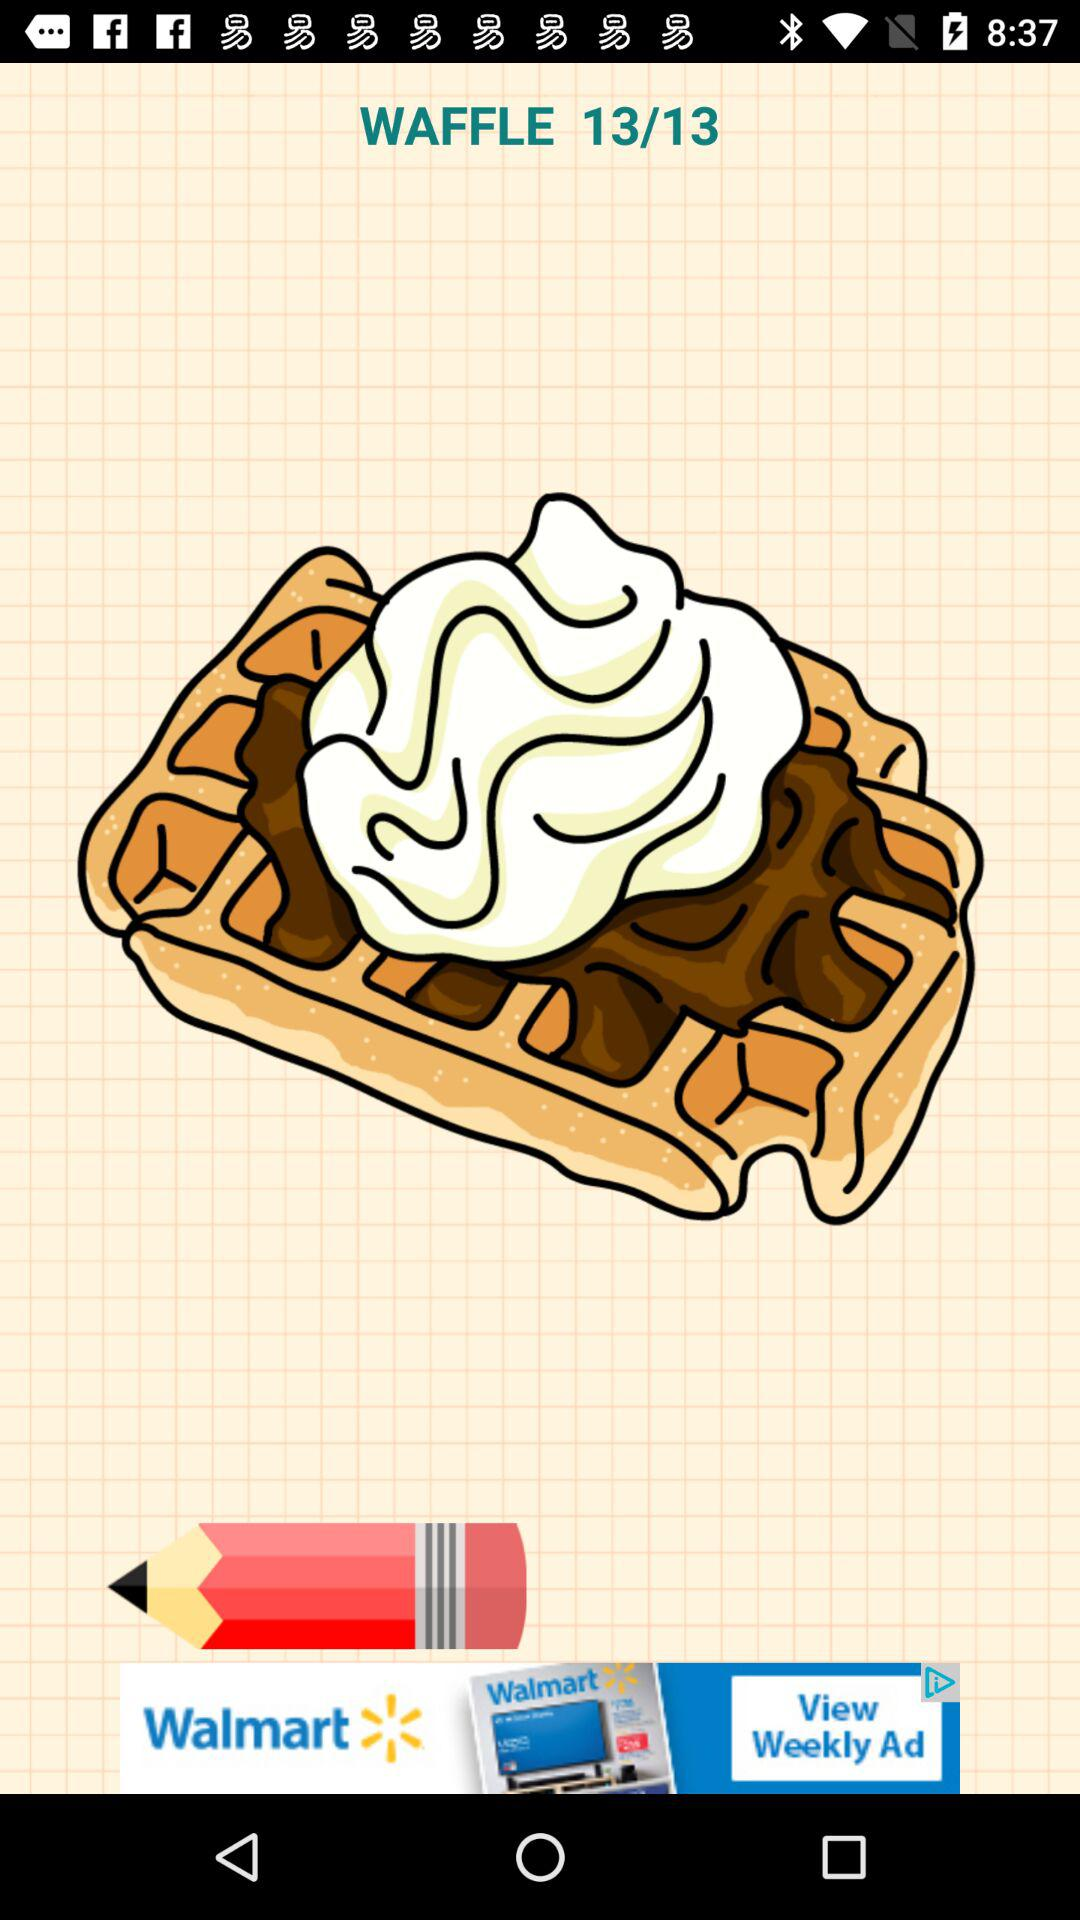How many total pages are there? There are 13 pages in total. 